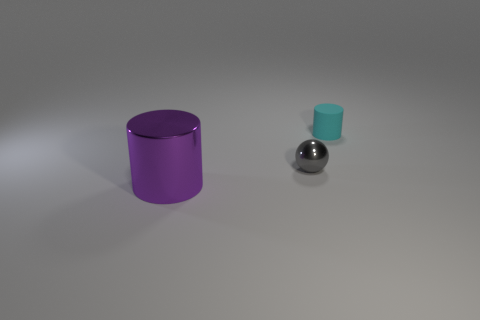Add 3 shiny balls. How many objects exist? 6 Subtract all cylinders. How many objects are left? 1 Subtract all gray spheres. Subtract all metallic cylinders. How many objects are left? 1 Add 1 purple things. How many purple things are left? 2 Add 1 rubber objects. How many rubber objects exist? 2 Subtract 0 brown spheres. How many objects are left? 3 